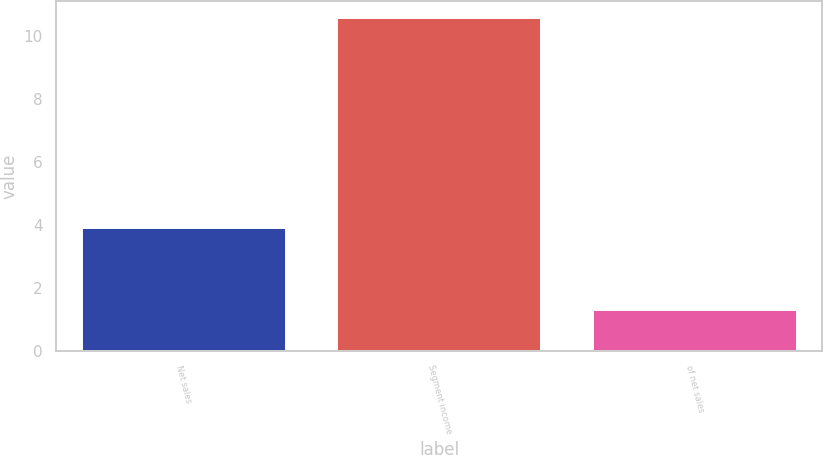Convert chart. <chart><loc_0><loc_0><loc_500><loc_500><bar_chart><fcel>Net sales<fcel>Segment income<fcel>of net sales<nl><fcel>3.9<fcel>10.6<fcel>1.3<nl></chart> 